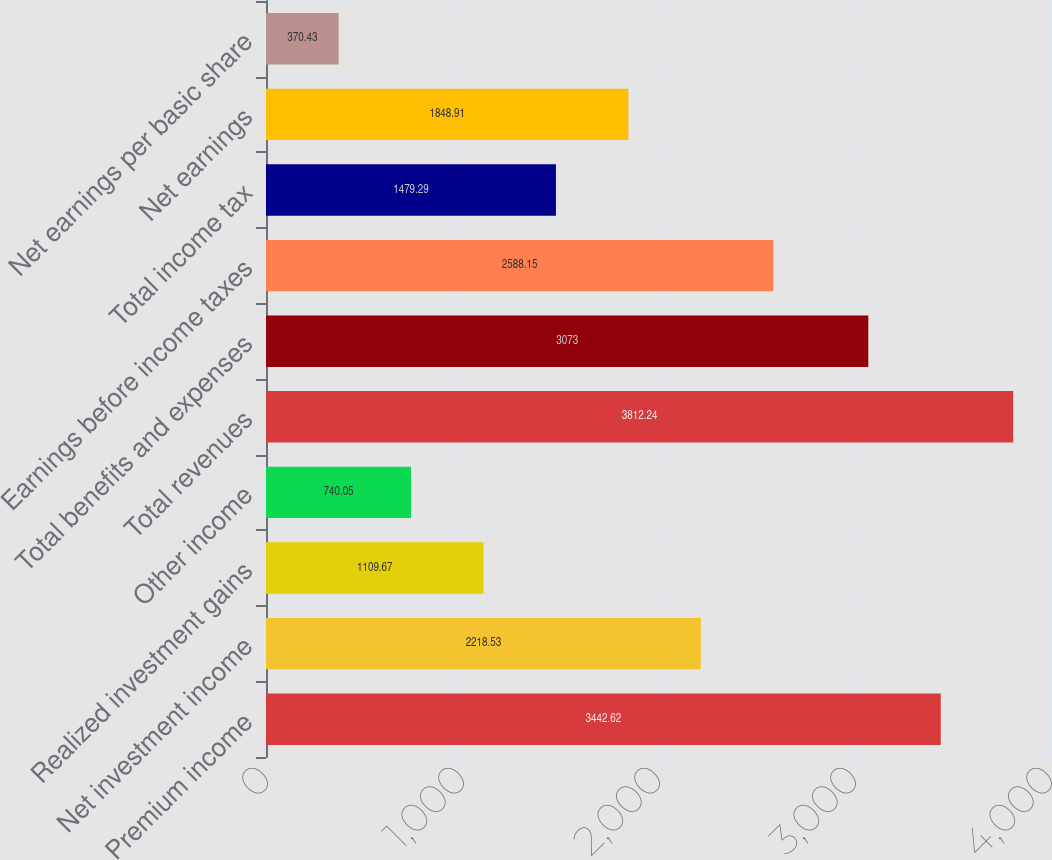Convert chart. <chart><loc_0><loc_0><loc_500><loc_500><bar_chart><fcel>Premium income<fcel>Net investment income<fcel>Realized investment gains<fcel>Other income<fcel>Total revenues<fcel>Total benefits and expenses<fcel>Earnings before income taxes<fcel>Total income tax<fcel>Net earnings<fcel>Net earnings per basic share<nl><fcel>3442.62<fcel>2218.53<fcel>1109.67<fcel>740.05<fcel>3812.24<fcel>3073<fcel>2588.15<fcel>1479.29<fcel>1848.91<fcel>370.43<nl></chart> 